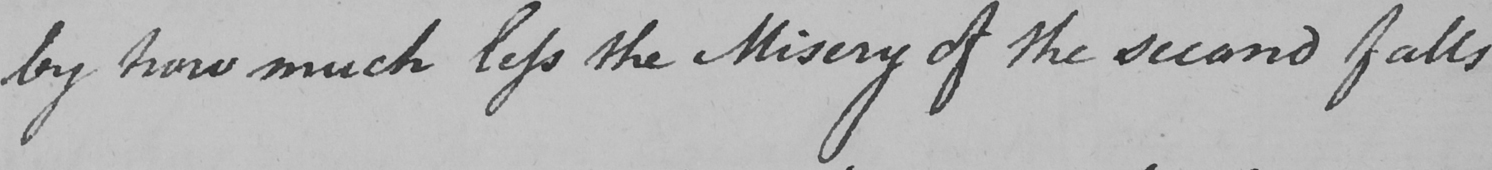What does this handwritten line say? by how much less the Misery of the second falls 